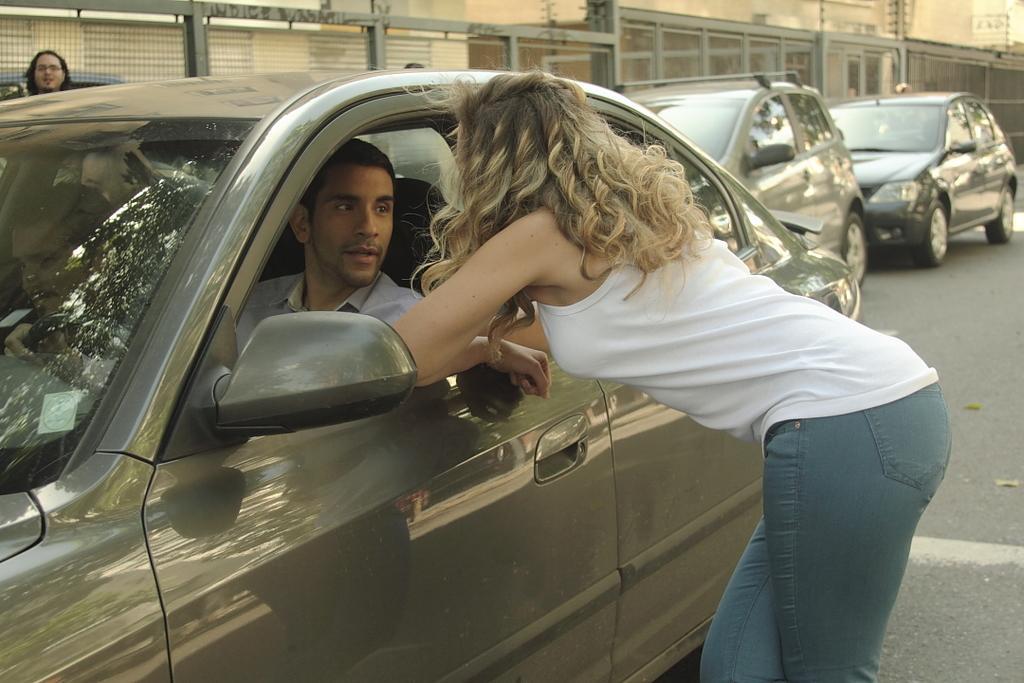Could you give a brief overview of what you see in this image? In this picture there is a woman standing near the door of a car and talking with this man he is looking at her and in the background there are some buildings and some other vehicles 